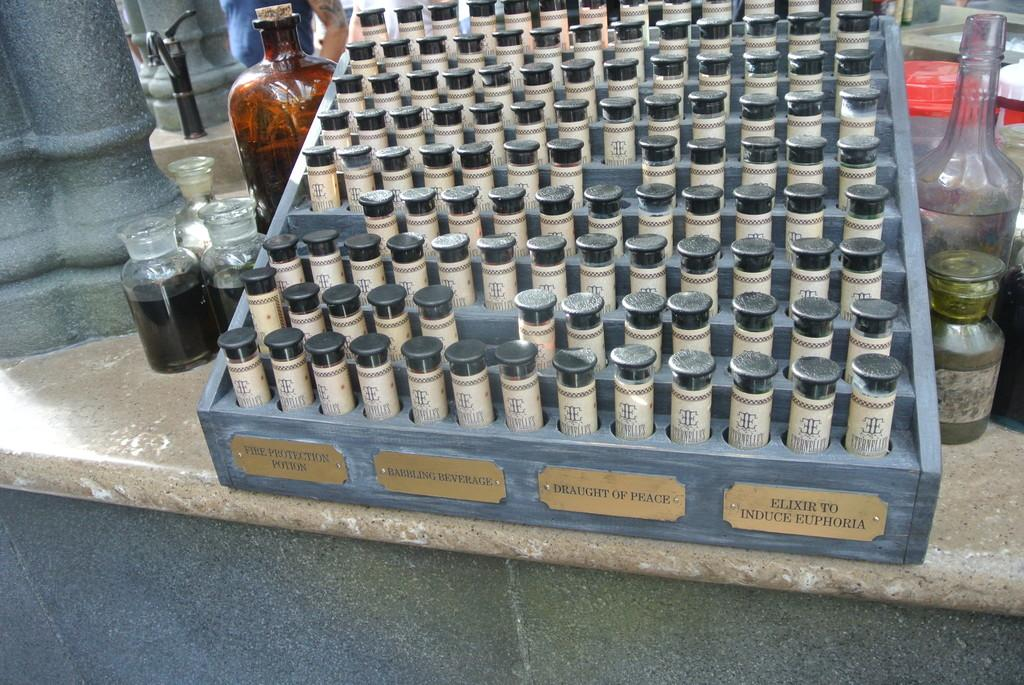<image>
Summarize the visual content of the image. A shelf full of small elixir vials that are labeled Draught of Peach. 